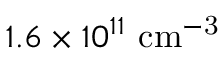Convert formula to latex. <formula><loc_0><loc_0><loc_500><loc_500>1 . 6 \times 1 0 ^ { 1 1 } { c m ^ { - 3 } }</formula> 